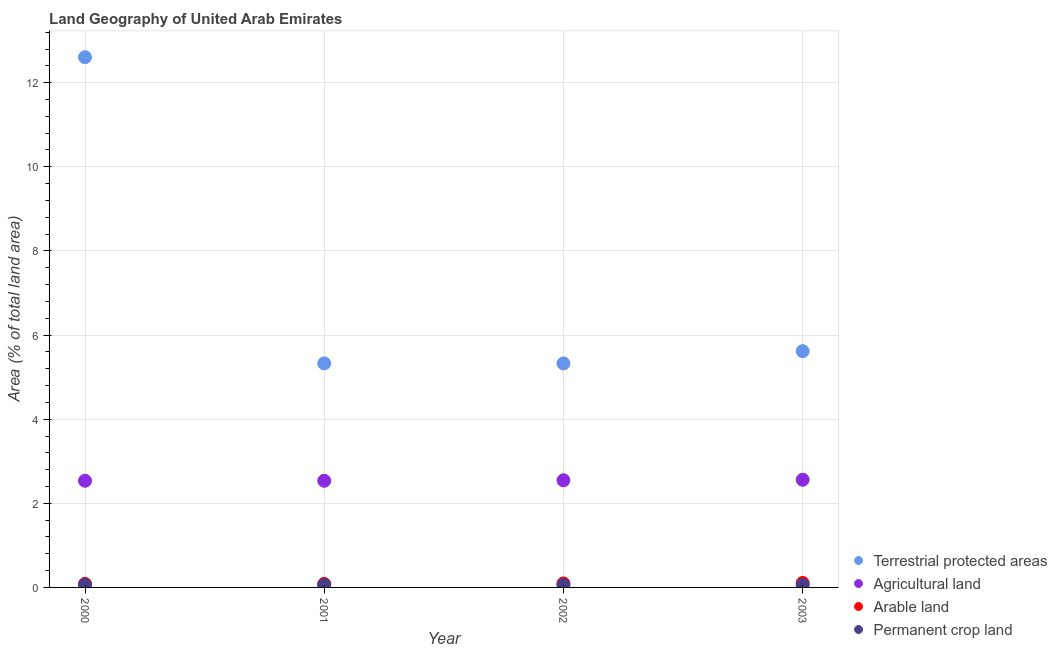How many different coloured dotlines are there?
Provide a succinct answer. 4. Is the number of dotlines equal to the number of legend labels?
Give a very brief answer. Yes. What is the percentage of area under arable land in 2003?
Your answer should be very brief. 0.11. Across all years, what is the maximum percentage of area under agricultural land?
Give a very brief answer. 2.56. Across all years, what is the minimum percentage of area under arable land?
Ensure brevity in your answer.  0.08. In which year was the percentage of area under arable land maximum?
Your answer should be very brief. 2003. In which year was the percentage of area under permanent crop land minimum?
Offer a very short reply. 2000. What is the total percentage of land under terrestrial protection in the graph?
Keep it short and to the point. 28.87. What is the difference between the percentage of land under terrestrial protection in 2000 and that in 2001?
Your response must be concise. 7.28. What is the difference between the percentage of area under agricultural land in 2001 and the percentage of land under terrestrial protection in 2002?
Provide a short and direct response. -2.79. What is the average percentage of area under agricultural land per year?
Provide a short and direct response. 2.54. In the year 2003, what is the difference between the percentage of area under permanent crop land and percentage of area under agricultural land?
Offer a terse response. -2.5. In how many years, is the percentage of area under permanent crop land greater than 1.2000000000000002 %?
Ensure brevity in your answer.  0. What is the ratio of the percentage of land under terrestrial protection in 2001 to that in 2003?
Offer a very short reply. 0.95. Is the percentage of area under permanent crop land in 2000 less than that in 2003?
Provide a short and direct response. No. Is the difference between the percentage of area under arable land in 2000 and 2002 greater than the difference between the percentage of area under agricultural land in 2000 and 2002?
Keep it short and to the point. Yes. In how many years, is the percentage of area under permanent crop land greater than the average percentage of area under permanent crop land taken over all years?
Make the answer very short. 0. Is it the case that in every year, the sum of the percentage of land under terrestrial protection and percentage of area under agricultural land is greater than the percentage of area under arable land?
Provide a succinct answer. Yes. Is the percentage of area under agricultural land strictly greater than the percentage of land under terrestrial protection over the years?
Make the answer very short. No. How many dotlines are there?
Give a very brief answer. 4. How many years are there in the graph?
Offer a terse response. 4. What is the difference between two consecutive major ticks on the Y-axis?
Ensure brevity in your answer.  2. Are the values on the major ticks of Y-axis written in scientific E-notation?
Offer a terse response. No. How many legend labels are there?
Provide a short and direct response. 4. How are the legend labels stacked?
Your response must be concise. Vertical. What is the title of the graph?
Offer a very short reply. Land Geography of United Arab Emirates. Does "Oil" appear as one of the legend labels in the graph?
Give a very brief answer. No. What is the label or title of the X-axis?
Offer a very short reply. Year. What is the label or title of the Y-axis?
Give a very brief answer. Area (% of total land area). What is the Area (% of total land area) of Terrestrial protected areas in 2000?
Provide a succinct answer. 12.61. What is the Area (% of total land area) in Agricultural land in 2000?
Provide a succinct answer. 2.54. What is the Area (% of total land area) in Arable land in 2000?
Offer a very short reply. 0.08. What is the Area (% of total land area) in Permanent crop land in 2000?
Offer a terse response. 0.06. What is the Area (% of total land area) of Terrestrial protected areas in 2001?
Your response must be concise. 5.33. What is the Area (% of total land area) in Agricultural land in 2001?
Offer a very short reply. 2.54. What is the Area (% of total land area) of Arable land in 2001?
Offer a very short reply. 0.08. What is the Area (% of total land area) of Permanent crop land in 2001?
Provide a short and direct response. 0.06. What is the Area (% of total land area) in Terrestrial protected areas in 2002?
Your answer should be compact. 5.33. What is the Area (% of total land area) in Agricultural land in 2002?
Offer a very short reply. 2.55. What is the Area (% of total land area) in Arable land in 2002?
Your answer should be compact. 0.1. What is the Area (% of total land area) of Permanent crop land in 2002?
Provide a short and direct response. 0.06. What is the Area (% of total land area) in Terrestrial protected areas in 2003?
Provide a short and direct response. 5.62. What is the Area (% of total land area) in Agricultural land in 2003?
Keep it short and to the point. 2.56. What is the Area (% of total land area) of Arable land in 2003?
Your response must be concise. 0.11. What is the Area (% of total land area) in Permanent crop land in 2003?
Your answer should be very brief. 0.06. Across all years, what is the maximum Area (% of total land area) in Terrestrial protected areas?
Give a very brief answer. 12.61. Across all years, what is the maximum Area (% of total land area) in Agricultural land?
Offer a very short reply. 2.56. Across all years, what is the maximum Area (% of total land area) of Arable land?
Give a very brief answer. 0.11. Across all years, what is the maximum Area (% of total land area) in Permanent crop land?
Your answer should be very brief. 0.06. Across all years, what is the minimum Area (% of total land area) in Terrestrial protected areas?
Provide a succinct answer. 5.33. Across all years, what is the minimum Area (% of total land area) of Agricultural land?
Make the answer very short. 2.54. Across all years, what is the minimum Area (% of total land area) of Arable land?
Ensure brevity in your answer.  0.08. Across all years, what is the minimum Area (% of total land area) of Permanent crop land?
Give a very brief answer. 0.06. What is the total Area (% of total land area) in Terrestrial protected areas in the graph?
Your answer should be very brief. 28.87. What is the total Area (% of total land area) of Agricultural land in the graph?
Keep it short and to the point. 10.18. What is the total Area (% of total land area) of Arable land in the graph?
Offer a very short reply. 0.37. What is the total Area (% of total land area) in Permanent crop land in the graph?
Give a very brief answer. 0.24. What is the difference between the Area (% of total land area) of Terrestrial protected areas in 2000 and that in 2001?
Keep it short and to the point. 7.28. What is the difference between the Area (% of total land area) in Agricultural land in 2000 and that in 2001?
Provide a succinct answer. 0. What is the difference between the Area (% of total land area) in Arable land in 2000 and that in 2001?
Ensure brevity in your answer.  0. What is the difference between the Area (% of total land area) of Terrestrial protected areas in 2000 and that in 2002?
Your answer should be very brief. 7.28. What is the difference between the Area (% of total land area) in Agricultural land in 2000 and that in 2002?
Provide a succinct answer. -0.01. What is the difference between the Area (% of total land area) of Arable land in 2000 and that in 2002?
Make the answer very short. -0.01. What is the difference between the Area (% of total land area) in Terrestrial protected areas in 2000 and that in 2003?
Your answer should be compact. 6.99. What is the difference between the Area (% of total land area) in Agricultural land in 2000 and that in 2003?
Give a very brief answer. -0.02. What is the difference between the Area (% of total land area) in Arable land in 2000 and that in 2003?
Offer a terse response. -0.02. What is the difference between the Area (% of total land area) in Permanent crop land in 2000 and that in 2003?
Your answer should be very brief. 0. What is the difference between the Area (% of total land area) in Terrestrial protected areas in 2001 and that in 2002?
Offer a very short reply. 0. What is the difference between the Area (% of total land area) in Agricultural land in 2001 and that in 2002?
Keep it short and to the point. -0.01. What is the difference between the Area (% of total land area) of Arable land in 2001 and that in 2002?
Your answer should be compact. -0.01. What is the difference between the Area (% of total land area) in Permanent crop land in 2001 and that in 2002?
Give a very brief answer. 0. What is the difference between the Area (% of total land area) in Terrestrial protected areas in 2001 and that in 2003?
Provide a succinct answer. -0.29. What is the difference between the Area (% of total land area) in Agricultural land in 2001 and that in 2003?
Provide a short and direct response. -0.02. What is the difference between the Area (% of total land area) of Arable land in 2001 and that in 2003?
Give a very brief answer. -0.02. What is the difference between the Area (% of total land area) of Terrestrial protected areas in 2002 and that in 2003?
Provide a succinct answer. -0.29. What is the difference between the Area (% of total land area) of Agricultural land in 2002 and that in 2003?
Offer a terse response. -0.01. What is the difference between the Area (% of total land area) of Arable land in 2002 and that in 2003?
Provide a succinct answer. -0.01. What is the difference between the Area (% of total land area) in Terrestrial protected areas in 2000 and the Area (% of total land area) in Agricultural land in 2001?
Offer a terse response. 10.07. What is the difference between the Area (% of total land area) in Terrestrial protected areas in 2000 and the Area (% of total land area) in Arable land in 2001?
Keep it short and to the point. 12.52. What is the difference between the Area (% of total land area) in Terrestrial protected areas in 2000 and the Area (% of total land area) in Permanent crop land in 2001?
Offer a terse response. 12.55. What is the difference between the Area (% of total land area) in Agricultural land in 2000 and the Area (% of total land area) in Arable land in 2001?
Keep it short and to the point. 2.45. What is the difference between the Area (% of total land area) in Agricultural land in 2000 and the Area (% of total land area) in Permanent crop land in 2001?
Ensure brevity in your answer.  2.48. What is the difference between the Area (% of total land area) of Arable land in 2000 and the Area (% of total land area) of Permanent crop land in 2001?
Provide a succinct answer. 0.02. What is the difference between the Area (% of total land area) in Terrestrial protected areas in 2000 and the Area (% of total land area) in Agricultural land in 2002?
Offer a terse response. 10.06. What is the difference between the Area (% of total land area) in Terrestrial protected areas in 2000 and the Area (% of total land area) in Arable land in 2002?
Provide a succinct answer. 12.51. What is the difference between the Area (% of total land area) of Terrestrial protected areas in 2000 and the Area (% of total land area) of Permanent crop land in 2002?
Give a very brief answer. 12.55. What is the difference between the Area (% of total land area) in Agricultural land in 2000 and the Area (% of total land area) in Arable land in 2002?
Ensure brevity in your answer.  2.44. What is the difference between the Area (% of total land area) in Agricultural land in 2000 and the Area (% of total land area) in Permanent crop land in 2002?
Your response must be concise. 2.48. What is the difference between the Area (% of total land area) in Arable land in 2000 and the Area (% of total land area) in Permanent crop land in 2002?
Your answer should be compact. 0.02. What is the difference between the Area (% of total land area) in Terrestrial protected areas in 2000 and the Area (% of total land area) in Agricultural land in 2003?
Your answer should be compact. 10.05. What is the difference between the Area (% of total land area) in Terrestrial protected areas in 2000 and the Area (% of total land area) in Arable land in 2003?
Keep it short and to the point. 12.5. What is the difference between the Area (% of total land area) in Terrestrial protected areas in 2000 and the Area (% of total land area) in Permanent crop land in 2003?
Provide a short and direct response. 12.55. What is the difference between the Area (% of total land area) in Agricultural land in 2000 and the Area (% of total land area) in Arable land in 2003?
Ensure brevity in your answer.  2.43. What is the difference between the Area (% of total land area) of Agricultural land in 2000 and the Area (% of total land area) of Permanent crop land in 2003?
Make the answer very short. 2.48. What is the difference between the Area (% of total land area) in Arable land in 2000 and the Area (% of total land area) in Permanent crop land in 2003?
Your response must be concise. 0.02. What is the difference between the Area (% of total land area) of Terrestrial protected areas in 2001 and the Area (% of total land area) of Agricultural land in 2002?
Make the answer very short. 2.78. What is the difference between the Area (% of total land area) in Terrestrial protected areas in 2001 and the Area (% of total land area) in Arable land in 2002?
Give a very brief answer. 5.23. What is the difference between the Area (% of total land area) in Terrestrial protected areas in 2001 and the Area (% of total land area) in Permanent crop land in 2002?
Keep it short and to the point. 5.27. What is the difference between the Area (% of total land area) in Agricultural land in 2001 and the Area (% of total land area) in Arable land in 2002?
Offer a terse response. 2.44. What is the difference between the Area (% of total land area) of Agricultural land in 2001 and the Area (% of total land area) of Permanent crop land in 2002?
Provide a succinct answer. 2.48. What is the difference between the Area (% of total land area) of Arable land in 2001 and the Area (% of total land area) of Permanent crop land in 2002?
Offer a terse response. 0.02. What is the difference between the Area (% of total land area) of Terrestrial protected areas in 2001 and the Area (% of total land area) of Agricultural land in 2003?
Offer a terse response. 2.77. What is the difference between the Area (% of total land area) in Terrestrial protected areas in 2001 and the Area (% of total land area) in Arable land in 2003?
Keep it short and to the point. 5.22. What is the difference between the Area (% of total land area) in Terrestrial protected areas in 2001 and the Area (% of total land area) in Permanent crop land in 2003?
Provide a short and direct response. 5.27. What is the difference between the Area (% of total land area) in Agricultural land in 2001 and the Area (% of total land area) in Arable land in 2003?
Your answer should be compact. 2.43. What is the difference between the Area (% of total land area) of Agricultural land in 2001 and the Area (% of total land area) of Permanent crop land in 2003?
Provide a short and direct response. 2.48. What is the difference between the Area (% of total land area) of Arable land in 2001 and the Area (% of total land area) of Permanent crop land in 2003?
Ensure brevity in your answer.  0.02. What is the difference between the Area (% of total land area) of Terrestrial protected areas in 2002 and the Area (% of total land area) of Agricultural land in 2003?
Your answer should be very brief. 2.77. What is the difference between the Area (% of total land area) of Terrestrial protected areas in 2002 and the Area (% of total land area) of Arable land in 2003?
Ensure brevity in your answer.  5.22. What is the difference between the Area (% of total land area) of Terrestrial protected areas in 2002 and the Area (% of total land area) of Permanent crop land in 2003?
Provide a short and direct response. 5.27. What is the difference between the Area (% of total land area) of Agricultural land in 2002 and the Area (% of total land area) of Arable land in 2003?
Make the answer very short. 2.44. What is the difference between the Area (% of total land area) in Agricultural land in 2002 and the Area (% of total land area) in Permanent crop land in 2003?
Your response must be concise. 2.49. What is the difference between the Area (% of total land area) of Arable land in 2002 and the Area (% of total land area) of Permanent crop land in 2003?
Provide a short and direct response. 0.04. What is the average Area (% of total land area) of Terrestrial protected areas per year?
Offer a terse response. 7.22. What is the average Area (% of total land area) of Agricultural land per year?
Provide a short and direct response. 2.54. What is the average Area (% of total land area) in Arable land per year?
Your answer should be compact. 0.09. What is the average Area (% of total land area) in Permanent crop land per year?
Offer a very short reply. 0.06. In the year 2000, what is the difference between the Area (% of total land area) of Terrestrial protected areas and Area (% of total land area) of Agricultural land?
Ensure brevity in your answer.  10.07. In the year 2000, what is the difference between the Area (% of total land area) of Terrestrial protected areas and Area (% of total land area) of Arable land?
Offer a terse response. 12.52. In the year 2000, what is the difference between the Area (% of total land area) in Terrestrial protected areas and Area (% of total land area) in Permanent crop land?
Ensure brevity in your answer.  12.55. In the year 2000, what is the difference between the Area (% of total land area) of Agricultural land and Area (% of total land area) of Arable land?
Make the answer very short. 2.45. In the year 2000, what is the difference between the Area (% of total land area) in Agricultural land and Area (% of total land area) in Permanent crop land?
Give a very brief answer. 2.48. In the year 2000, what is the difference between the Area (% of total land area) in Arable land and Area (% of total land area) in Permanent crop land?
Provide a short and direct response. 0.02. In the year 2001, what is the difference between the Area (% of total land area) in Terrestrial protected areas and Area (% of total land area) in Agricultural land?
Your response must be concise. 2.79. In the year 2001, what is the difference between the Area (% of total land area) of Terrestrial protected areas and Area (% of total land area) of Arable land?
Keep it short and to the point. 5.24. In the year 2001, what is the difference between the Area (% of total land area) in Terrestrial protected areas and Area (% of total land area) in Permanent crop land?
Ensure brevity in your answer.  5.27. In the year 2001, what is the difference between the Area (% of total land area) in Agricultural land and Area (% of total land area) in Arable land?
Ensure brevity in your answer.  2.45. In the year 2001, what is the difference between the Area (% of total land area) of Agricultural land and Area (% of total land area) of Permanent crop land?
Your answer should be compact. 2.48. In the year 2001, what is the difference between the Area (% of total land area) in Arable land and Area (% of total land area) in Permanent crop land?
Provide a short and direct response. 0.02. In the year 2002, what is the difference between the Area (% of total land area) in Terrestrial protected areas and Area (% of total land area) in Agricultural land?
Your answer should be very brief. 2.78. In the year 2002, what is the difference between the Area (% of total land area) in Terrestrial protected areas and Area (% of total land area) in Arable land?
Your answer should be compact. 5.23. In the year 2002, what is the difference between the Area (% of total land area) in Terrestrial protected areas and Area (% of total land area) in Permanent crop land?
Make the answer very short. 5.27. In the year 2002, what is the difference between the Area (% of total land area) of Agricultural land and Area (% of total land area) of Arable land?
Provide a succinct answer. 2.45. In the year 2002, what is the difference between the Area (% of total land area) in Agricultural land and Area (% of total land area) in Permanent crop land?
Make the answer very short. 2.49. In the year 2002, what is the difference between the Area (% of total land area) of Arable land and Area (% of total land area) of Permanent crop land?
Provide a succinct answer. 0.04. In the year 2003, what is the difference between the Area (% of total land area) of Terrestrial protected areas and Area (% of total land area) of Agricultural land?
Make the answer very short. 3.06. In the year 2003, what is the difference between the Area (% of total land area) of Terrestrial protected areas and Area (% of total land area) of Arable land?
Give a very brief answer. 5.51. In the year 2003, what is the difference between the Area (% of total land area) in Terrestrial protected areas and Area (% of total land area) in Permanent crop land?
Provide a succinct answer. 5.56. In the year 2003, what is the difference between the Area (% of total land area) in Agricultural land and Area (% of total land area) in Arable land?
Provide a short and direct response. 2.45. In the year 2003, what is the difference between the Area (% of total land area) in Arable land and Area (% of total land area) in Permanent crop land?
Ensure brevity in your answer.  0.05. What is the ratio of the Area (% of total land area) of Terrestrial protected areas in 2000 to that in 2001?
Give a very brief answer. 2.37. What is the ratio of the Area (% of total land area) of Terrestrial protected areas in 2000 to that in 2002?
Offer a very short reply. 2.37. What is the ratio of the Area (% of total land area) of Arable land in 2000 to that in 2002?
Your answer should be compact. 0.88. What is the ratio of the Area (% of total land area) in Permanent crop land in 2000 to that in 2002?
Give a very brief answer. 1. What is the ratio of the Area (% of total land area) of Terrestrial protected areas in 2000 to that in 2003?
Offer a terse response. 2.24. What is the ratio of the Area (% of total land area) in Agricultural land in 2000 to that in 2003?
Your response must be concise. 0.99. What is the ratio of the Area (% of total land area) of Permanent crop land in 2000 to that in 2003?
Offer a very short reply. 1. What is the ratio of the Area (% of total land area) of Terrestrial protected areas in 2001 to that in 2002?
Keep it short and to the point. 1. What is the ratio of the Area (% of total land area) in Agricultural land in 2001 to that in 2002?
Provide a succinct answer. 1. What is the ratio of the Area (% of total land area) of Arable land in 2001 to that in 2002?
Offer a terse response. 0.88. What is the ratio of the Area (% of total land area) of Permanent crop land in 2001 to that in 2002?
Provide a short and direct response. 1. What is the ratio of the Area (% of total land area) of Terrestrial protected areas in 2001 to that in 2003?
Your answer should be compact. 0.95. What is the ratio of the Area (% of total land area) in Arable land in 2001 to that in 2003?
Offer a terse response. 0.78. What is the ratio of the Area (% of total land area) of Terrestrial protected areas in 2002 to that in 2003?
Make the answer very short. 0.95. What is the ratio of the Area (% of total land area) in Agricultural land in 2002 to that in 2003?
Offer a terse response. 1. What is the ratio of the Area (% of total land area) in Permanent crop land in 2002 to that in 2003?
Keep it short and to the point. 1. What is the difference between the highest and the second highest Area (% of total land area) in Terrestrial protected areas?
Keep it short and to the point. 6.99. What is the difference between the highest and the second highest Area (% of total land area) of Agricultural land?
Provide a succinct answer. 0.01. What is the difference between the highest and the second highest Area (% of total land area) in Arable land?
Your answer should be very brief. 0.01. What is the difference between the highest and the lowest Area (% of total land area) of Terrestrial protected areas?
Offer a very short reply. 7.28. What is the difference between the highest and the lowest Area (% of total land area) of Agricultural land?
Provide a succinct answer. 0.02. What is the difference between the highest and the lowest Area (% of total land area) of Arable land?
Keep it short and to the point. 0.02. What is the difference between the highest and the lowest Area (% of total land area) in Permanent crop land?
Provide a short and direct response. 0. 